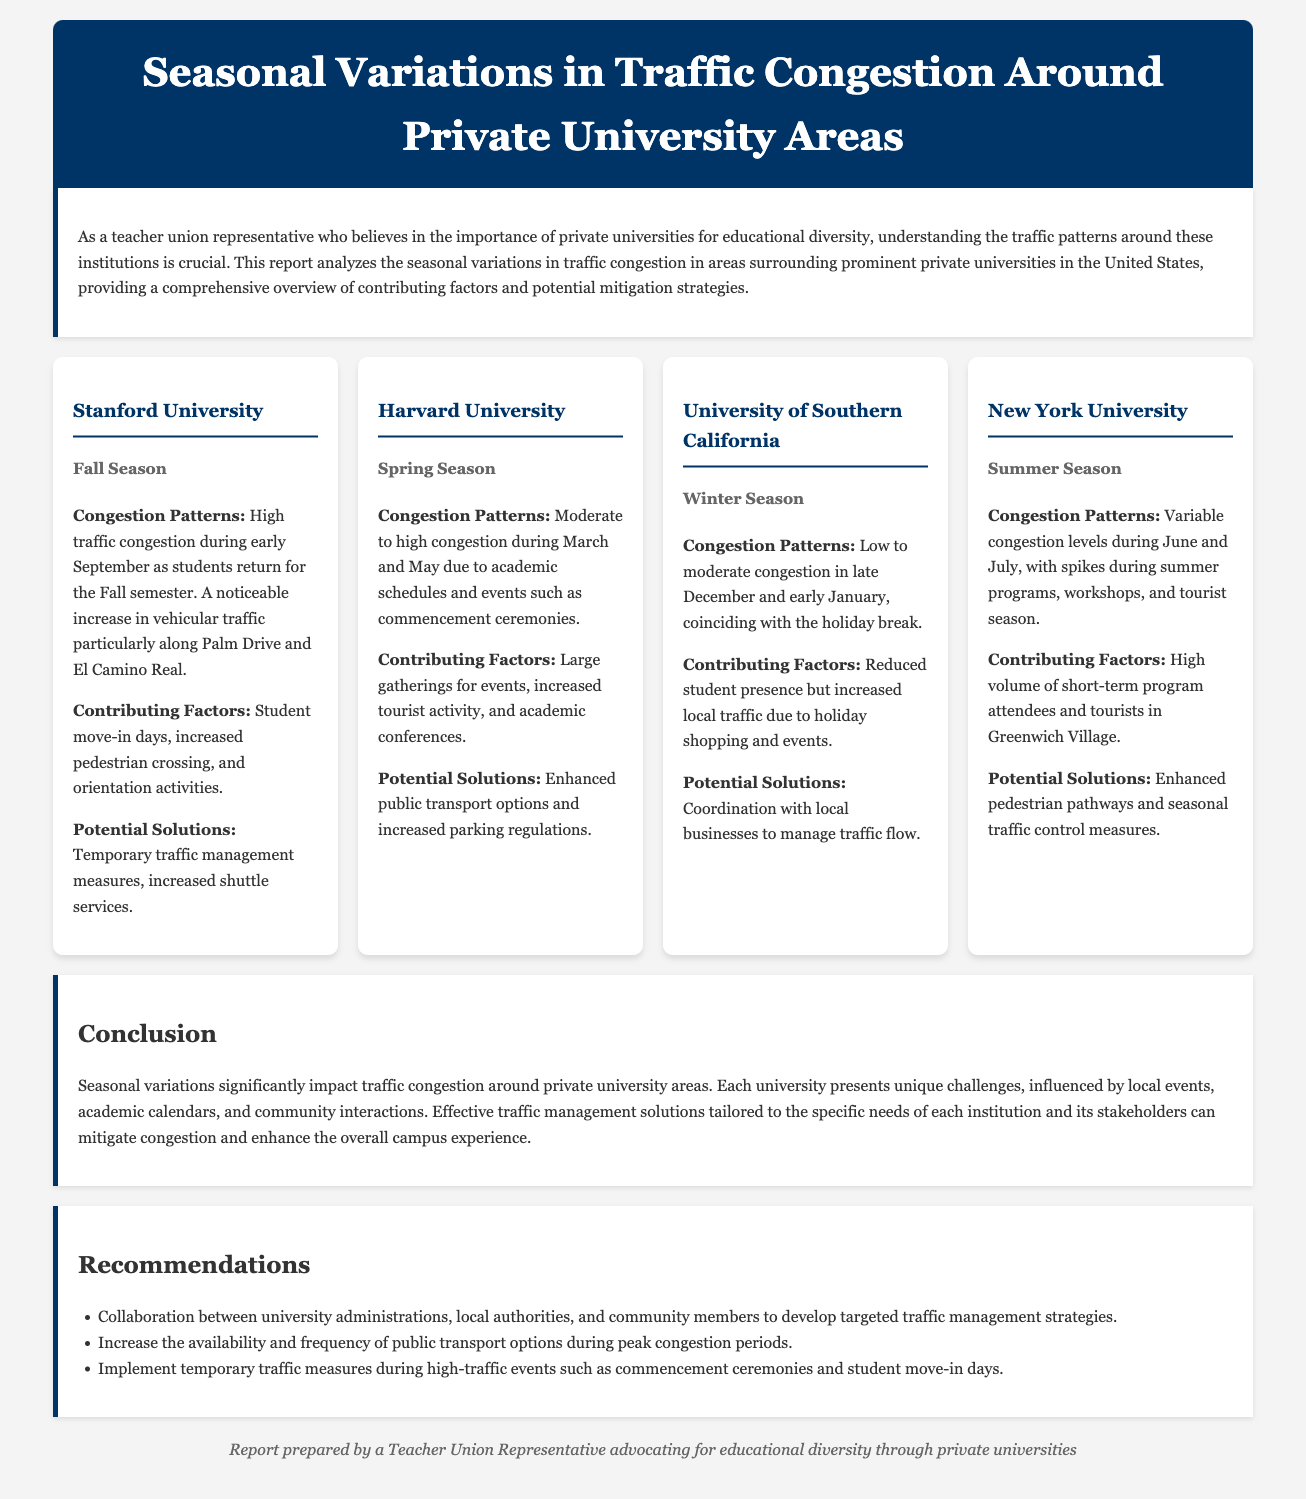What is the title of the report? The title is presented in the header section of the document.
Answer: Seasonal Variations in Traffic Congestion Around Private University Areas Which season shows high congestion at Stanford University? This information can be found in the section describing congestion patterns for each university.
Answer: Fall Season During which months does Harvard University experience moderate to high congestion? The months are specified in relation to the spring season events mentioned.
Answer: March and May What contributing factor is mentioned for congestion around New York University? This detail is provided in the section discussing the reasons for congestion.
Answer: High volume of short-term program attendees and tourists What is a potential solution suggested for traffic congestion at Stanford University? The report lists possible solutions for each university under the respective sections.
Answer: Increased shuttle services Which university experiences low to moderate congestion during the winter season? The specific university is stated in the context of seasonal traffic patterns.
Answer: University of Southern California What is the main conclusion of the report regarding traffic congestion? The conclusion summarizes the overall findings related to traffic management in private university areas.
Answer: Seasonal variations significantly impact traffic congestion around private university areas What type of collaboration is recommended in the report? The recommendations highlight various collaborative efforts suggested for effective traffic management.
Answer: Collaboration between university administrations, local authorities, and community members 